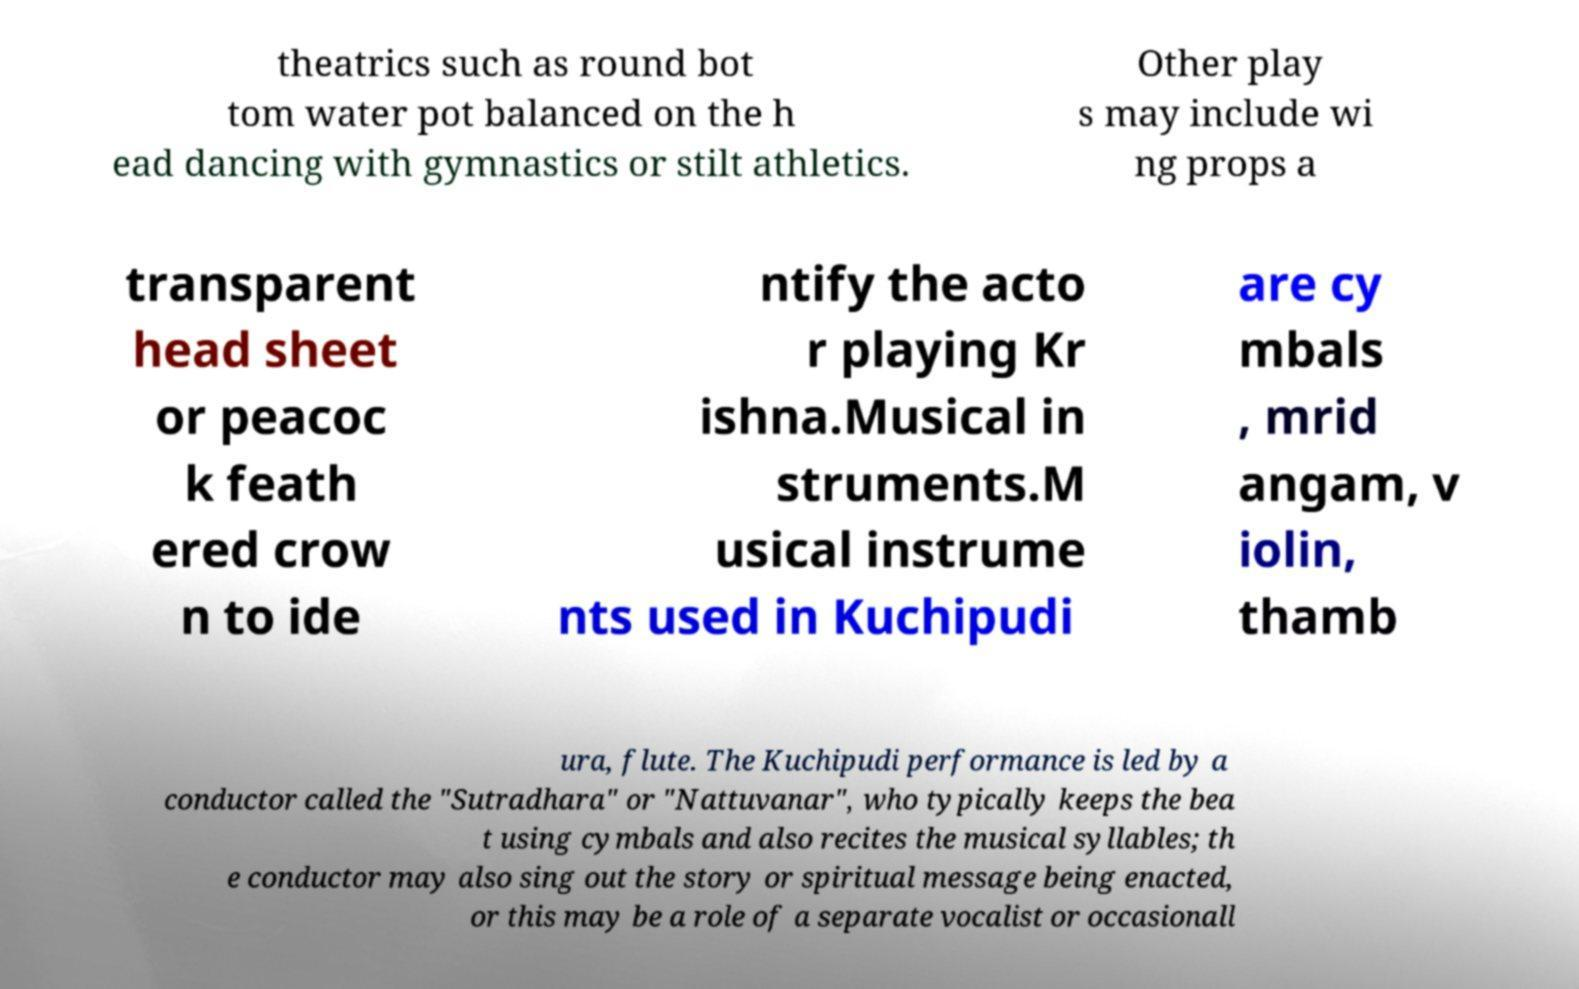I need the written content from this picture converted into text. Can you do that? theatrics such as round bot tom water pot balanced on the h ead dancing with gymnastics or stilt athletics. Other play s may include wi ng props a transparent head sheet or peacoc k feath ered crow n to ide ntify the acto r playing Kr ishna.Musical in struments.M usical instrume nts used in Kuchipudi are cy mbals , mrid angam, v iolin, thamb ura, flute. The Kuchipudi performance is led by a conductor called the "Sutradhara" or "Nattuvanar", who typically keeps the bea t using cymbals and also recites the musical syllables; th e conductor may also sing out the story or spiritual message being enacted, or this may be a role of a separate vocalist or occasionall 